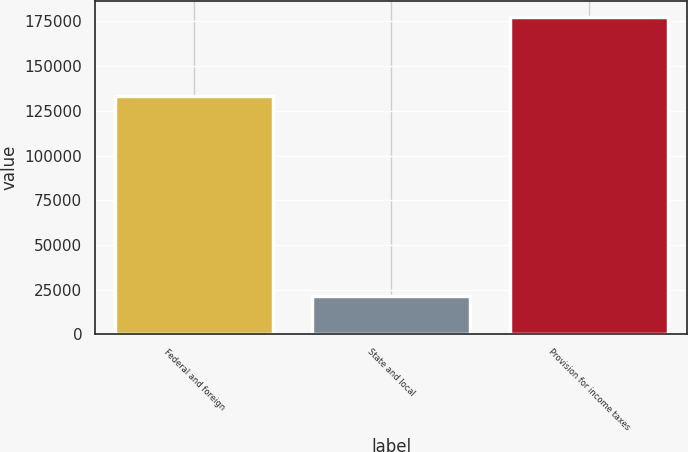<chart> <loc_0><loc_0><loc_500><loc_500><bar_chart><fcel>Federal and foreign<fcel>State and local<fcel>Provision for income taxes<nl><fcel>133043<fcel>21343<fcel>177663<nl></chart> 